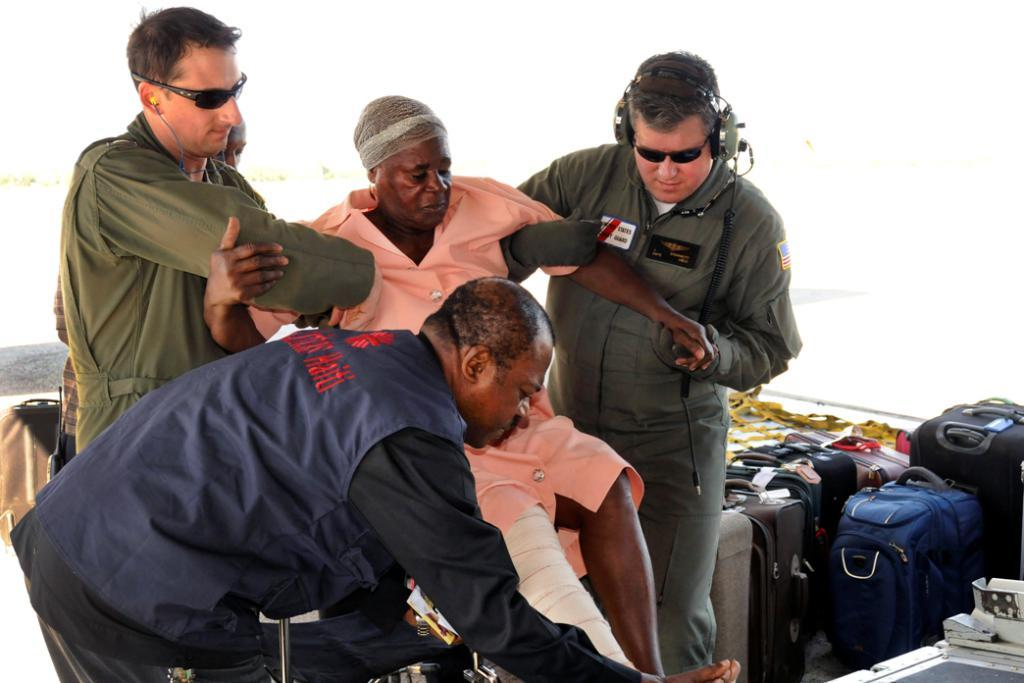What is happening in the image involving the person and the old man? There is a person holding an old man in the image. What can be seen on the right side of the image? There is luggage on the right side of the image. What type of rings can be seen on the wire in the image? There is no wire or rings present in the image. What kind of machine is visible in the background of the image? There is no machine visible in the image. 